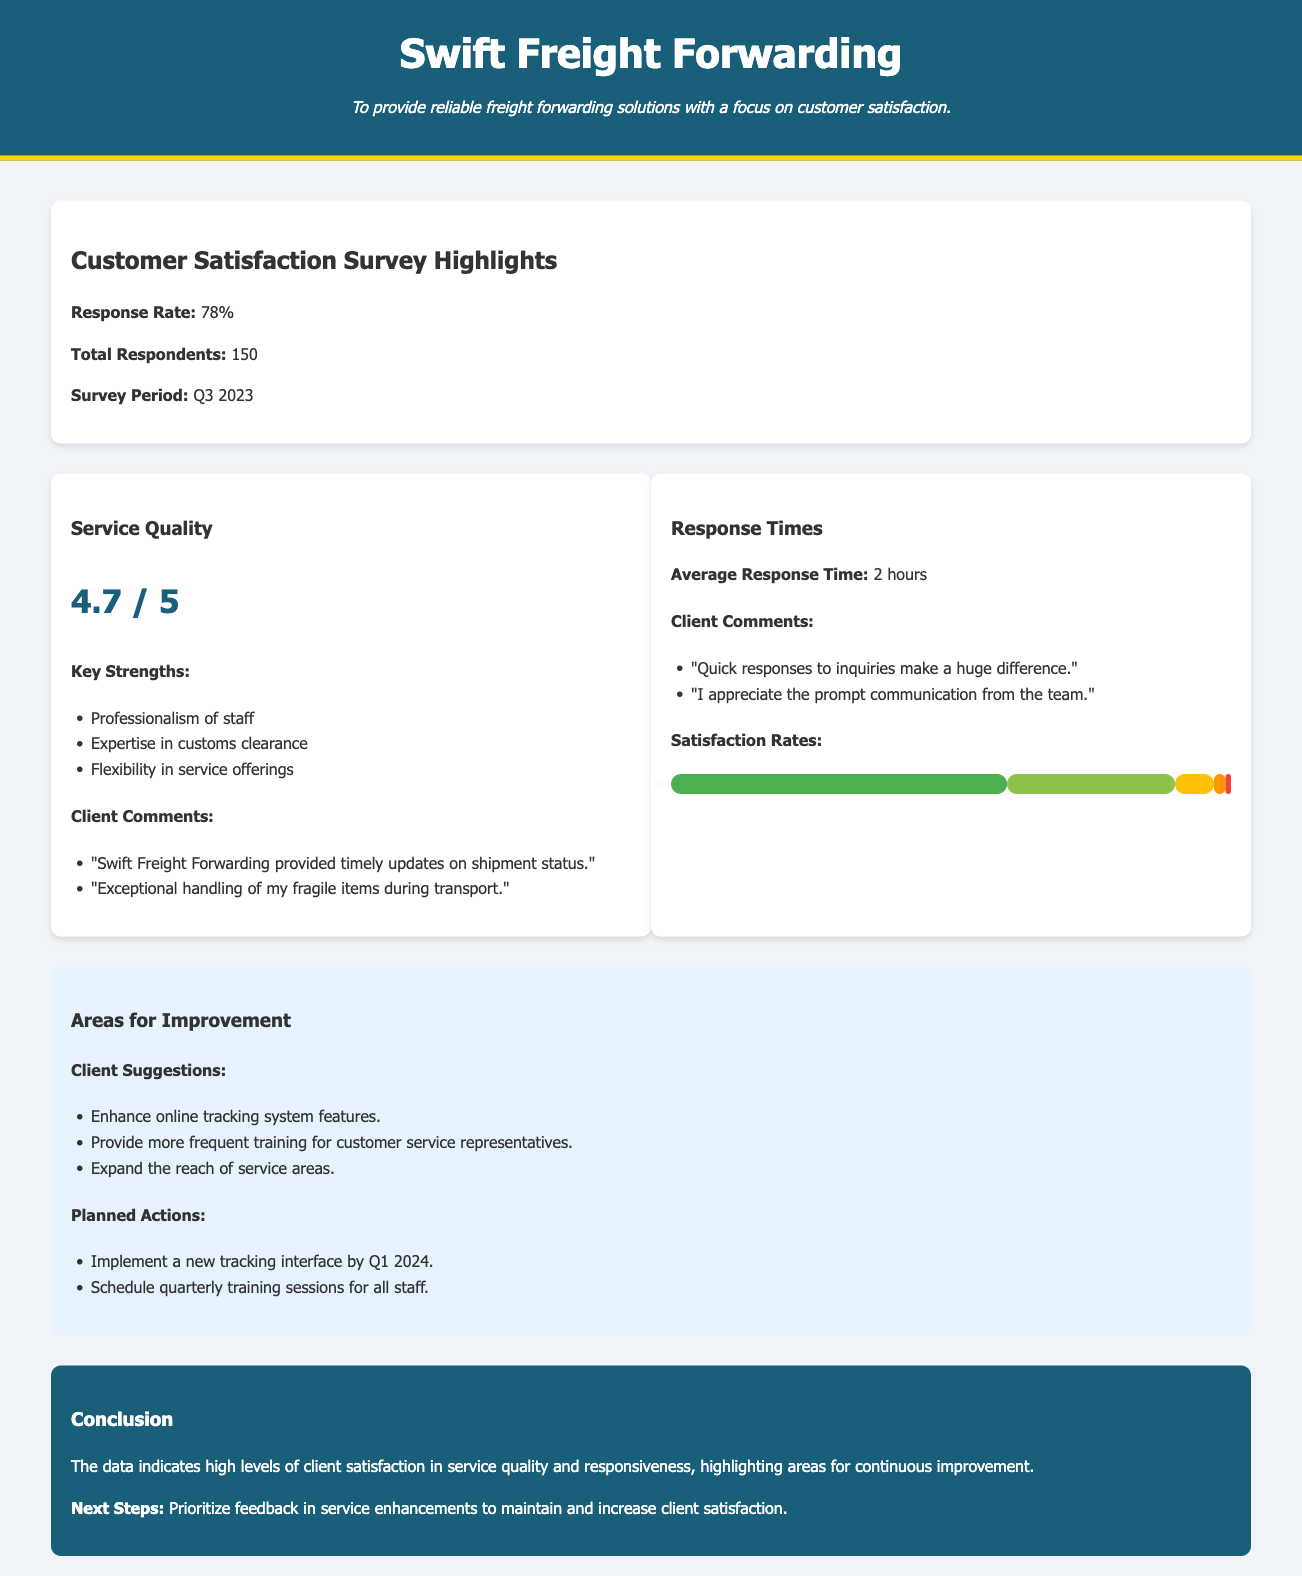What is the response rate? The response rate indicates the percentage of clients who completed the survey, which is 78%.
Answer: 78% What is the average response time? The average response time measures how quickly the company responds to inquiries, which is stated as 2 hours.
Answer: 2 hours How many total respondents participated in the survey? The total respondents refer to the number of clients who provided feedback, which is 150.
Answer: 150 What is the service quality rating? The service quality rating reflects the clients' satisfaction level, which is shown as 4.7 out of 5.
Answer: 4.7 / 5 What percentage of clients are very satisfied with response times? This percentage is derived from the satisfaction rates shown in the document, noted as 60%.
Answer: 60% What areas for improvement did clients suggest? The areas for improvement include suggestions made by clients, which list enhancing online tracking and providing more training.
Answer: Enhance online tracking system features What are the planned actions stated in the document? The planned actions outline the steps the company intends to take for improvement, including implementing a new tracking interface.
Answer: Implement a new tracking interface by Q1 2024 What is the mission statement of Swift Freight Forwarding? The mission statement describes the company's focus on reliability and customer satisfaction.
Answer: To provide reliable freight forwarding solutions with a focus on customer satisfaction What is highlighted in the conclusion section? The conclusion summarizes the overall findings, highlighting client satisfaction and areas for improvement.
Answer: High levels of client satisfaction in service quality and responsiveness 